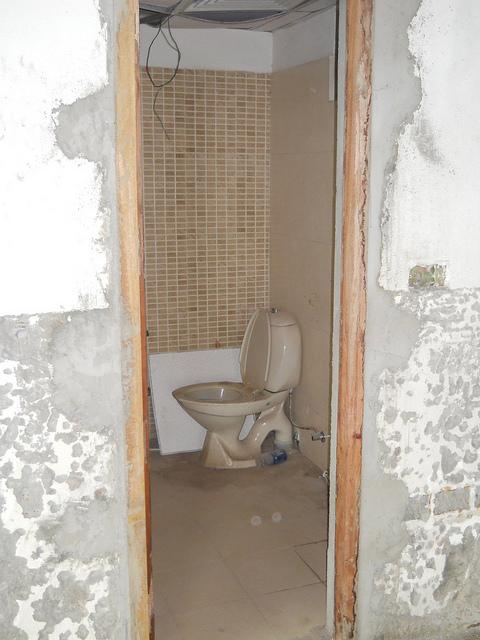Does this look sanitary?
Give a very brief answer. No. Are there tiles on the wall?
Give a very brief answer. Yes. Is the wire supposed to be hanging from the ceiling?
Concise answer only. No. 